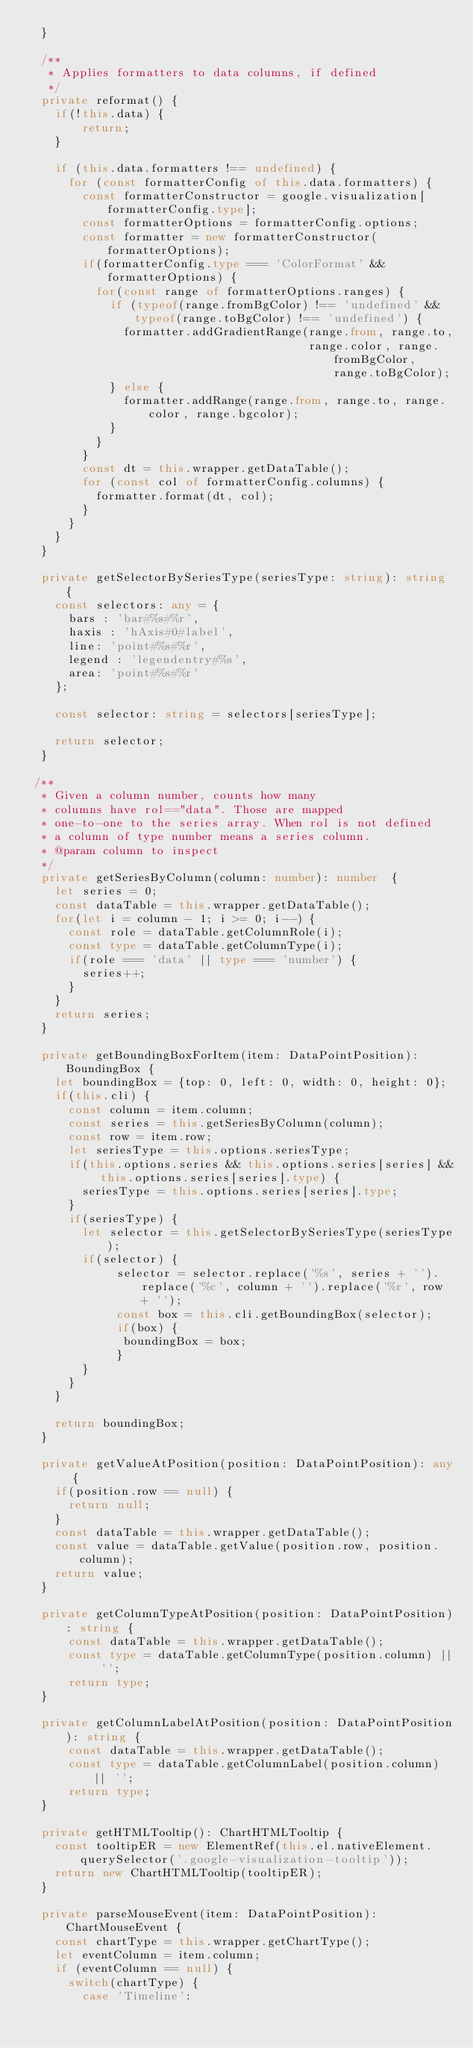Convert code to text. <code><loc_0><loc_0><loc_500><loc_500><_TypeScript_>  }

  /**
   * Applies formatters to data columns, if defined
   */
  private reformat() {
    if(!this.data) {
        return;
    }

    if (this.data.formatters !== undefined) {
      for (const formatterConfig of this.data.formatters) {
        const formatterConstructor = google.visualization[formatterConfig.type];
        const formatterOptions = formatterConfig.options;
        const formatter = new formatterConstructor(formatterOptions);
        if(formatterConfig.type === 'ColorFormat' && formatterOptions) {
          for(const range of formatterOptions.ranges) {
            if (typeof(range.fromBgColor) !== 'undefined' && typeof(range.toBgColor) !== 'undefined') {
              formatter.addGradientRange(range.from, range.to,
                                         range.color, range.fromBgColor, range.toBgColor);
            } else {
              formatter.addRange(range.from, range.to, range.color, range.bgcolor);
            }
          }
        }
        const dt = this.wrapper.getDataTable();
        for (const col of formatterConfig.columns) {
          formatter.format(dt, col);
        }
      }
    }
  }

  private getSelectorBySeriesType(seriesType: string): string {
    const selectors: any = {
      bars : 'bar#%s#%r',
      haxis : 'hAxis#0#label',
      line: 'point#%s#%r',
      legend : 'legendentry#%s',
      area: 'point#%s#%r'
    };

    const selector: string = selectors[seriesType];

    return selector;
  }

 /**
  * Given a column number, counts how many
  * columns have rol=="data". Those are mapped
  * one-to-one to the series array. When rol is not defined
  * a column of type number means a series column.
  * @param column to inspect
  */
  private getSeriesByColumn(column: number): number  {
    let series = 0;
    const dataTable = this.wrapper.getDataTable();
    for(let i = column - 1; i >= 0; i--) {
      const role = dataTable.getColumnRole(i);
      const type = dataTable.getColumnType(i);
      if(role === 'data' || type === 'number') {
        series++;
      }
    }
    return series;
  }

  private getBoundingBoxForItem(item: DataPointPosition): BoundingBox {
    let boundingBox = {top: 0, left: 0, width: 0, height: 0};
    if(this.cli) {
      const column = item.column;
      const series = this.getSeriesByColumn(column);
      const row = item.row;
      let seriesType = this.options.seriesType;
      if(this.options.series && this.options.series[series] && this.options.series[series].type) {
        seriesType = this.options.series[series].type;
      }
      if(seriesType) {
        let selector = this.getSelectorBySeriesType(seriesType);
        if(selector) {
             selector = selector.replace('%s', series + '').replace('%c', column + '').replace('%r', row + '');
             const box = this.cli.getBoundingBox(selector);
             if(box) {
              boundingBox = box;
             }
        }
      }
    }

    return boundingBox;
  }

  private getValueAtPosition(position: DataPointPosition): any {
    if(position.row == null) {
      return null;
    }
    const dataTable = this.wrapper.getDataTable();
    const value = dataTable.getValue(position.row, position.column);
    return value;
  }

  private getColumnTypeAtPosition(position: DataPointPosition): string {
      const dataTable = this.wrapper.getDataTable();
      const type = dataTable.getColumnType(position.column) || '';
      return type;
  }

  private getColumnLabelAtPosition(position: DataPointPosition): string {
      const dataTable = this.wrapper.getDataTable();
      const type = dataTable.getColumnLabel(position.column) || '';
      return type;
  }

  private getHTMLTooltip(): ChartHTMLTooltip {
    const tooltipER = new ElementRef(this.el.nativeElement.querySelector('.google-visualization-tooltip'));
    return new ChartHTMLTooltip(tooltipER);
  }

  private parseMouseEvent(item: DataPointPosition): ChartMouseEvent {
    const chartType = this.wrapper.getChartType();
    let eventColumn = item.column;
    if (eventColumn == null) {
      switch(chartType) {
        case 'Timeline':</code> 